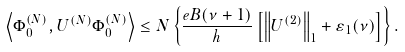Convert formula to latex. <formula><loc_0><loc_0><loc_500><loc_500>\left \langle \Phi _ { 0 } ^ { ( N ) } , U ^ { ( N ) } \Phi _ { 0 } ^ { ( N ) } \right \rangle \leq N \left \{ \frac { e B ( \nu + 1 ) } { h } \left [ \left \| U ^ { ( 2 ) } \right \| _ { 1 } + \varepsilon _ { 1 } ( \nu ) \right ] \right \} .</formula> 